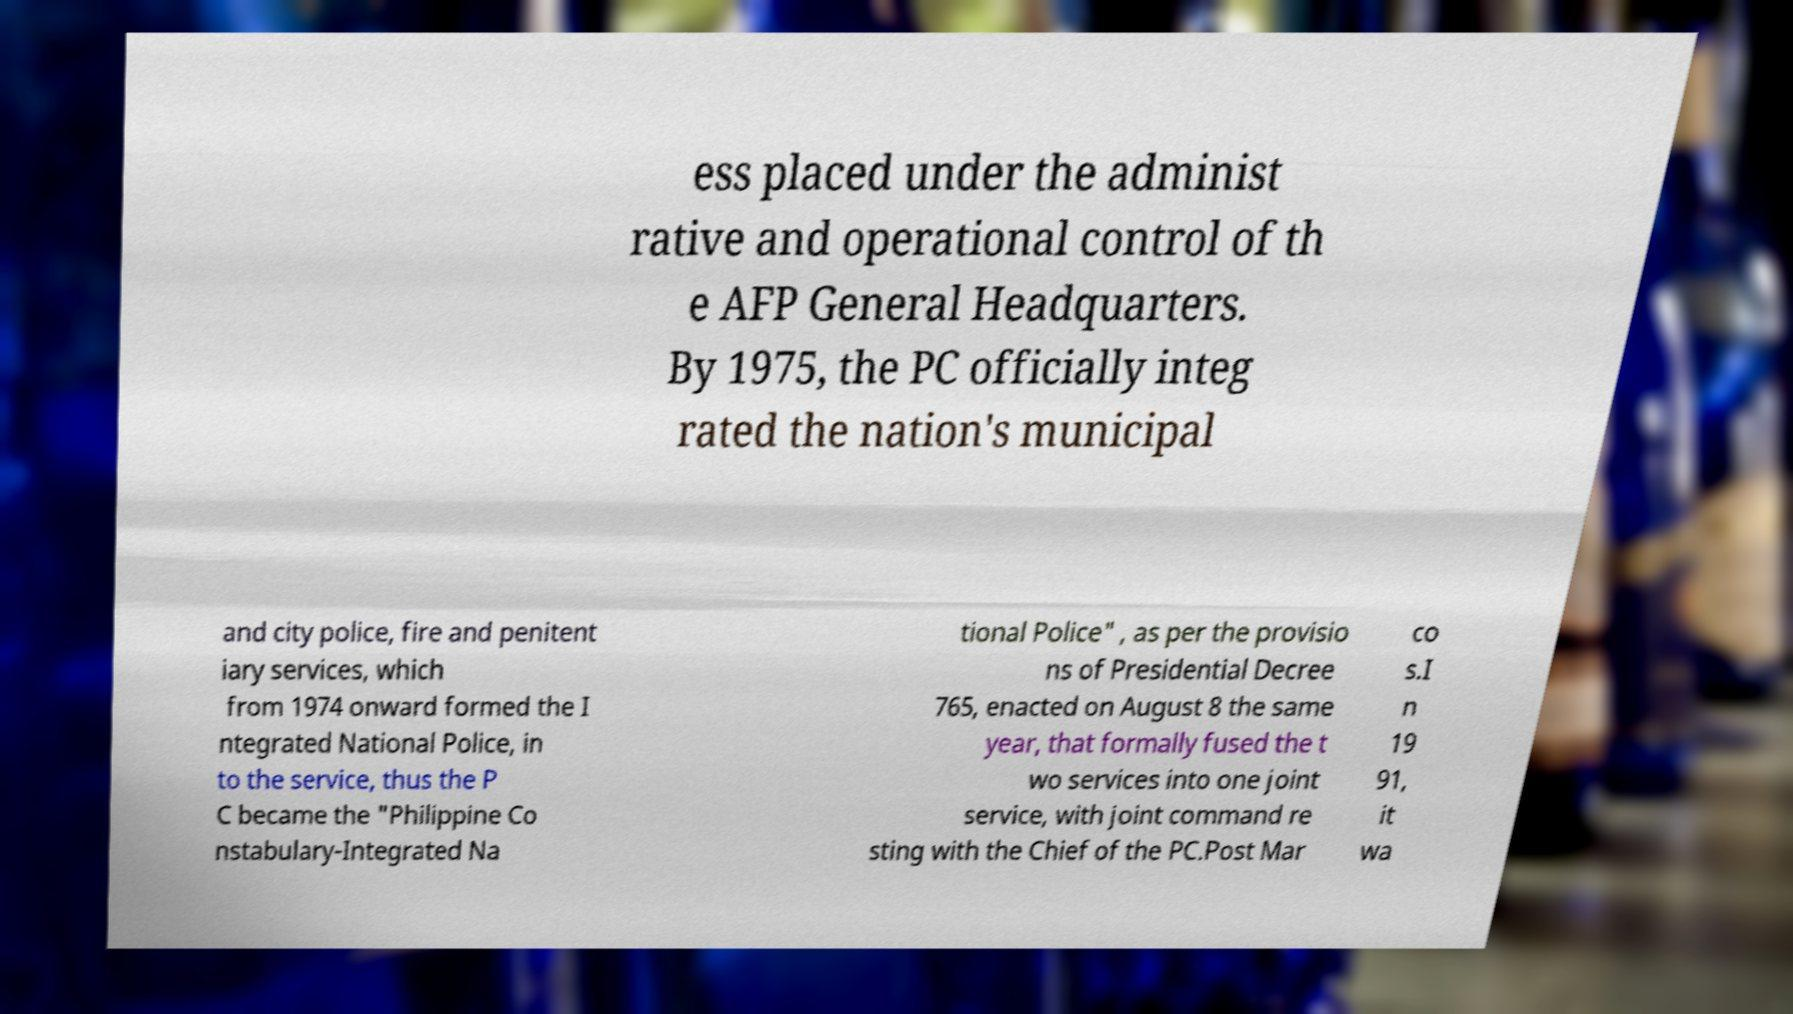There's text embedded in this image that I need extracted. Can you transcribe it verbatim? ess placed under the administ rative and operational control of th e AFP General Headquarters. By 1975, the PC officially integ rated the nation's municipal and city police, fire and penitent iary services, which from 1974 onward formed the I ntegrated National Police, in to the service, thus the P C became the "Philippine Co nstabulary-Integrated Na tional Police" , as per the provisio ns of Presidential Decree 765, enacted on August 8 the same year, that formally fused the t wo services into one joint service, with joint command re sting with the Chief of the PC.Post Mar co s.I n 19 91, it wa 